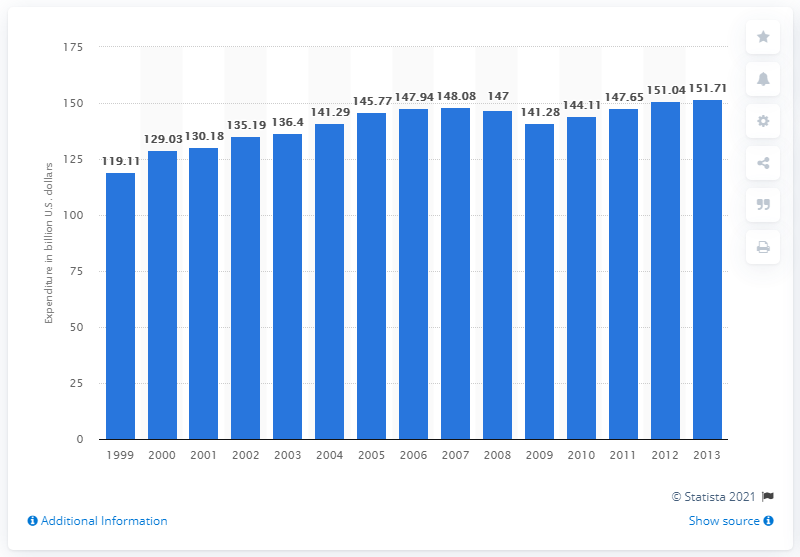Point out several critical features in this image. In 2013, consumer spending on arts and culture related items in the United States amounted to 151.71. 